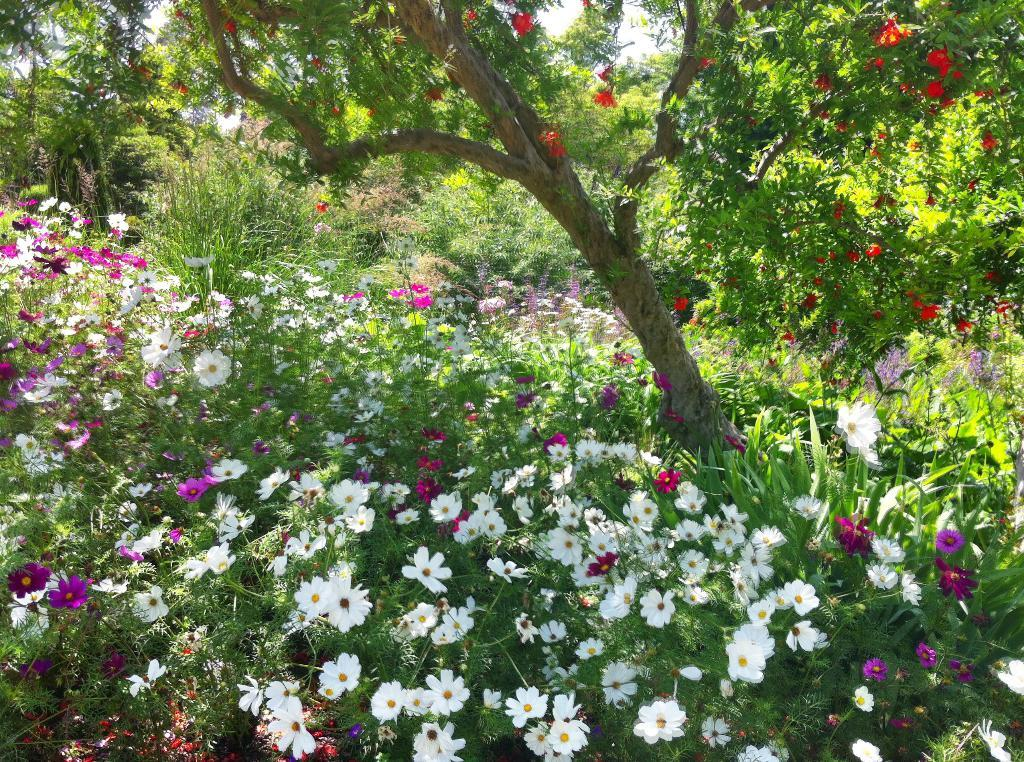What type of vegetation can be seen in the image? There are flowers, plants, and trees in the image. What part of the natural environment is visible in the image? The sky is visible in the image. What type of advertisement can be seen on the tree in the image? There is no advertisement present on the tree in the image. Can you describe the bee's behavior on the flowers in the image? There are no bees present in the image; it only features flowers, plants, trees, and the sky. 